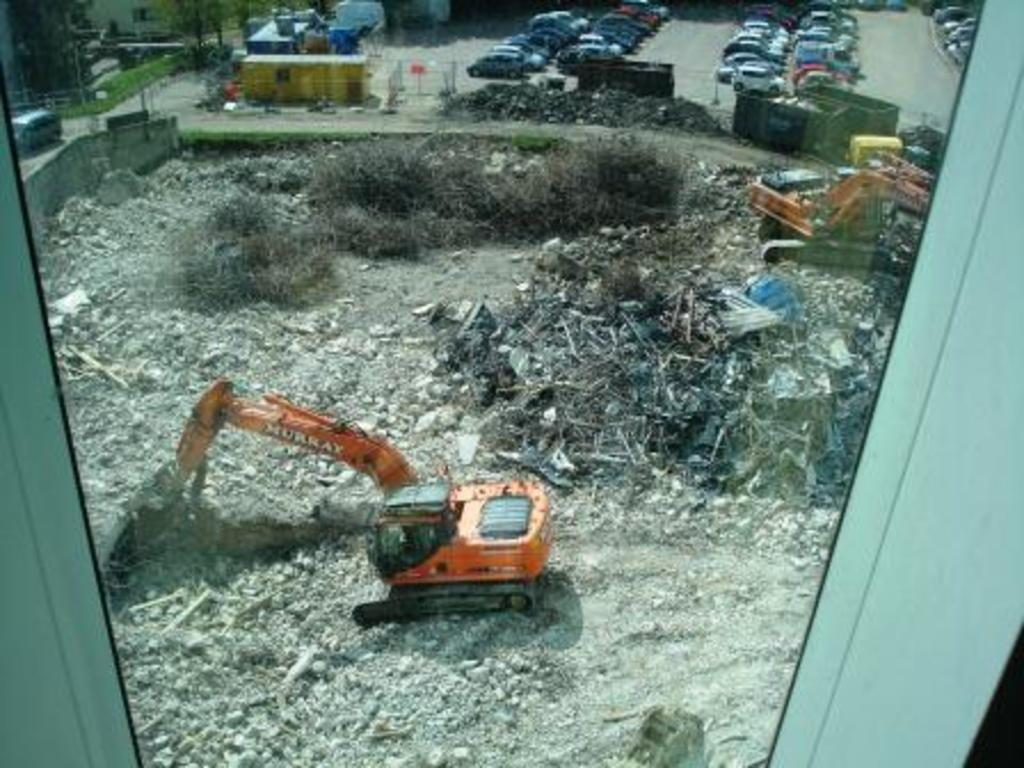What types of vehicles can be seen on the road in the image? There are vehicles on the road in the image. What specific type of machinery is present in the image? There are bulldozers in the image. What type of vegetation can be seen in the image? There are dried plants and grass in the image. What type of dress is the teacher wearing in the image? There is no teacher or dress present in the image. What type of class is being conducted in the image? There is no class or educational setting depicted in the image. 